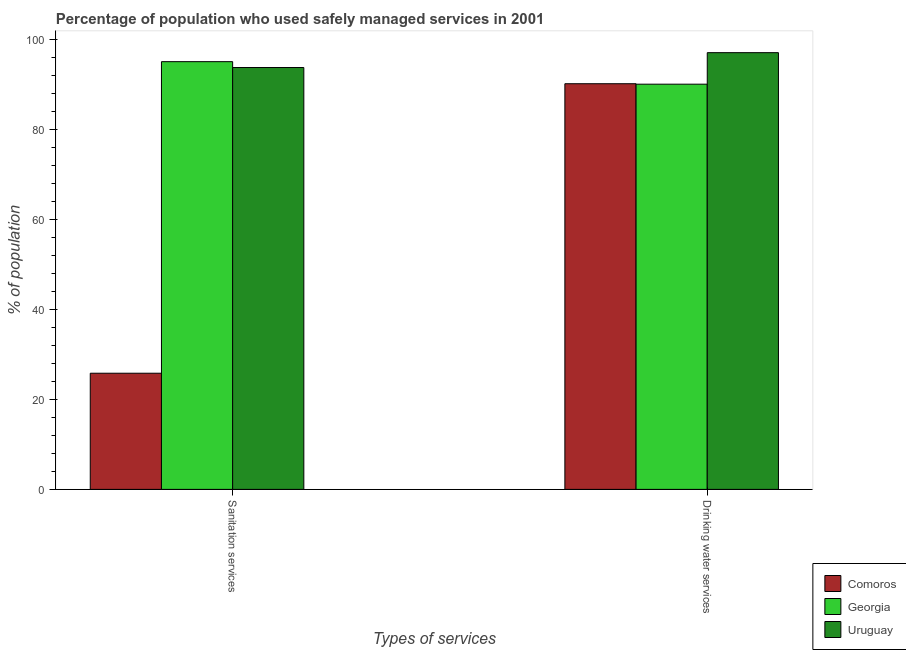Are the number of bars per tick equal to the number of legend labels?
Offer a very short reply. Yes. Are the number of bars on each tick of the X-axis equal?
Your response must be concise. Yes. How many bars are there on the 1st tick from the right?
Ensure brevity in your answer.  3. What is the label of the 1st group of bars from the left?
Your answer should be very brief. Sanitation services. Across all countries, what is the maximum percentage of population who used sanitation services?
Your answer should be very brief. 95. Across all countries, what is the minimum percentage of population who used drinking water services?
Your answer should be compact. 90. In which country was the percentage of population who used sanitation services maximum?
Give a very brief answer. Georgia. In which country was the percentage of population who used sanitation services minimum?
Offer a terse response. Comoros. What is the total percentage of population who used drinking water services in the graph?
Make the answer very short. 277.1. What is the difference between the percentage of population who used sanitation services in Georgia and that in Comoros?
Ensure brevity in your answer.  69.2. What is the difference between the percentage of population who used drinking water services in Georgia and the percentage of population who used sanitation services in Uruguay?
Your answer should be very brief. -3.7. What is the average percentage of population who used drinking water services per country?
Your answer should be compact. 92.37. What is the difference between the percentage of population who used drinking water services and percentage of population who used sanitation services in Comoros?
Provide a short and direct response. 64.3. What is the ratio of the percentage of population who used sanitation services in Georgia to that in Uruguay?
Offer a very short reply. 1.01. Is the percentage of population who used drinking water services in Georgia less than that in Uruguay?
Your answer should be very brief. Yes. What does the 2nd bar from the left in Sanitation services represents?
Provide a short and direct response. Georgia. What does the 3rd bar from the right in Drinking water services represents?
Your response must be concise. Comoros. How many bars are there?
Give a very brief answer. 6. Are all the bars in the graph horizontal?
Provide a short and direct response. No. What is the difference between two consecutive major ticks on the Y-axis?
Offer a terse response. 20. Are the values on the major ticks of Y-axis written in scientific E-notation?
Offer a terse response. No. Does the graph contain any zero values?
Ensure brevity in your answer.  No. Where does the legend appear in the graph?
Offer a very short reply. Bottom right. How many legend labels are there?
Offer a very short reply. 3. How are the legend labels stacked?
Give a very brief answer. Vertical. What is the title of the graph?
Ensure brevity in your answer.  Percentage of population who used safely managed services in 2001. What is the label or title of the X-axis?
Ensure brevity in your answer.  Types of services. What is the label or title of the Y-axis?
Offer a terse response. % of population. What is the % of population of Comoros in Sanitation services?
Provide a succinct answer. 25.8. What is the % of population of Uruguay in Sanitation services?
Ensure brevity in your answer.  93.7. What is the % of population in Comoros in Drinking water services?
Keep it short and to the point. 90.1. What is the % of population in Uruguay in Drinking water services?
Your answer should be very brief. 97. Across all Types of services, what is the maximum % of population in Comoros?
Provide a short and direct response. 90.1. Across all Types of services, what is the maximum % of population in Georgia?
Make the answer very short. 95. Across all Types of services, what is the maximum % of population of Uruguay?
Make the answer very short. 97. Across all Types of services, what is the minimum % of population in Comoros?
Give a very brief answer. 25.8. Across all Types of services, what is the minimum % of population in Georgia?
Your response must be concise. 90. Across all Types of services, what is the minimum % of population in Uruguay?
Keep it short and to the point. 93.7. What is the total % of population of Comoros in the graph?
Your answer should be very brief. 115.9. What is the total % of population in Georgia in the graph?
Keep it short and to the point. 185. What is the total % of population of Uruguay in the graph?
Offer a very short reply. 190.7. What is the difference between the % of population in Comoros in Sanitation services and that in Drinking water services?
Ensure brevity in your answer.  -64.3. What is the difference between the % of population in Georgia in Sanitation services and that in Drinking water services?
Make the answer very short. 5. What is the difference between the % of population of Uruguay in Sanitation services and that in Drinking water services?
Offer a terse response. -3.3. What is the difference between the % of population in Comoros in Sanitation services and the % of population in Georgia in Drinking water services?
Your answer should be compact. -64.2. What is the difference between the % of population in Comoros in Sanitation services and the % of population in Uruguay in Drinking water services?
Offer a very short reply. -71.2. What is the average % of population of Comoros per Types of services?
Your answer should be compact. 57.95. What is the average % of population of Georgia per Types of services?
Give a very brief answer. 92.5. What is the average % of population of Uruguay per Types of services?
Keep it short and to the point. 95.35. What is the difference between the % of population of Comoros and % of population of Georgia in Sanitation services?
Your response must be concise. -69.2. What is the difference between the % of population in Comoros and % of population in Uruguay in Sanitation services?
Offer a terse response. -67.9. What is the difference between the % of population of Georgia and % of population of Uruguay in Sanitation services?
Offer a very short reply. 1.3. What is the difference between the % of population in Comoros and % of population in Georgia in Drinking water services?
Provide a short and direct response. 0.1. What is the ratio of the % of population of Comoros in Sanitation services to that in Drinking water services?
Make the answer very short. 0.29. What is the ratio of the % of population of Georgia in Sanitation services to that in Drinking water services?
Offer a very short reply. 1.06. What is the difference between the highest and the second highest % of population in Comoros?
Provide a short and direct response. 64.3. What is the difference between the highest and the lowest % of population of Comoros?
Your answer should be very brief. 64.3. What is the difference between the highest and the lowest % of population in Georgia?
Offer a terse response. 5. 